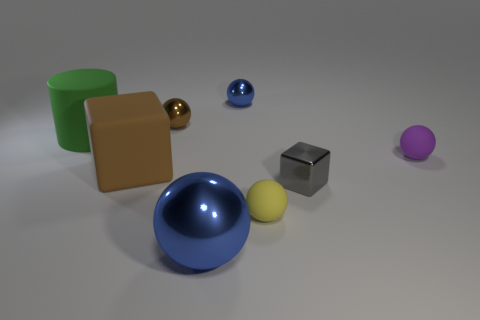Subtract all large balls. How many balls are left? 4 Subtract all purple spheres. How many spheres are left? 4 Add 1 yellow shiny cylinders. How many objects exist? 9 Subtract all balls. How many objects are left? 3 Add 5 blue metal objects. How many blue metal objects exist? 7 Subtract 0 cyan cubes. How many objects are left? 8 Subtract 4 balls. How many balls are left? 1 Subtract all gray blocks. Subtract all cyan cylinders. How many blocks are left? 1 Subtract all brown spheres. How many brown cubes are left? 1 Subtract all tiny gray things. Subtract all small balls. How many objects are left? 3 